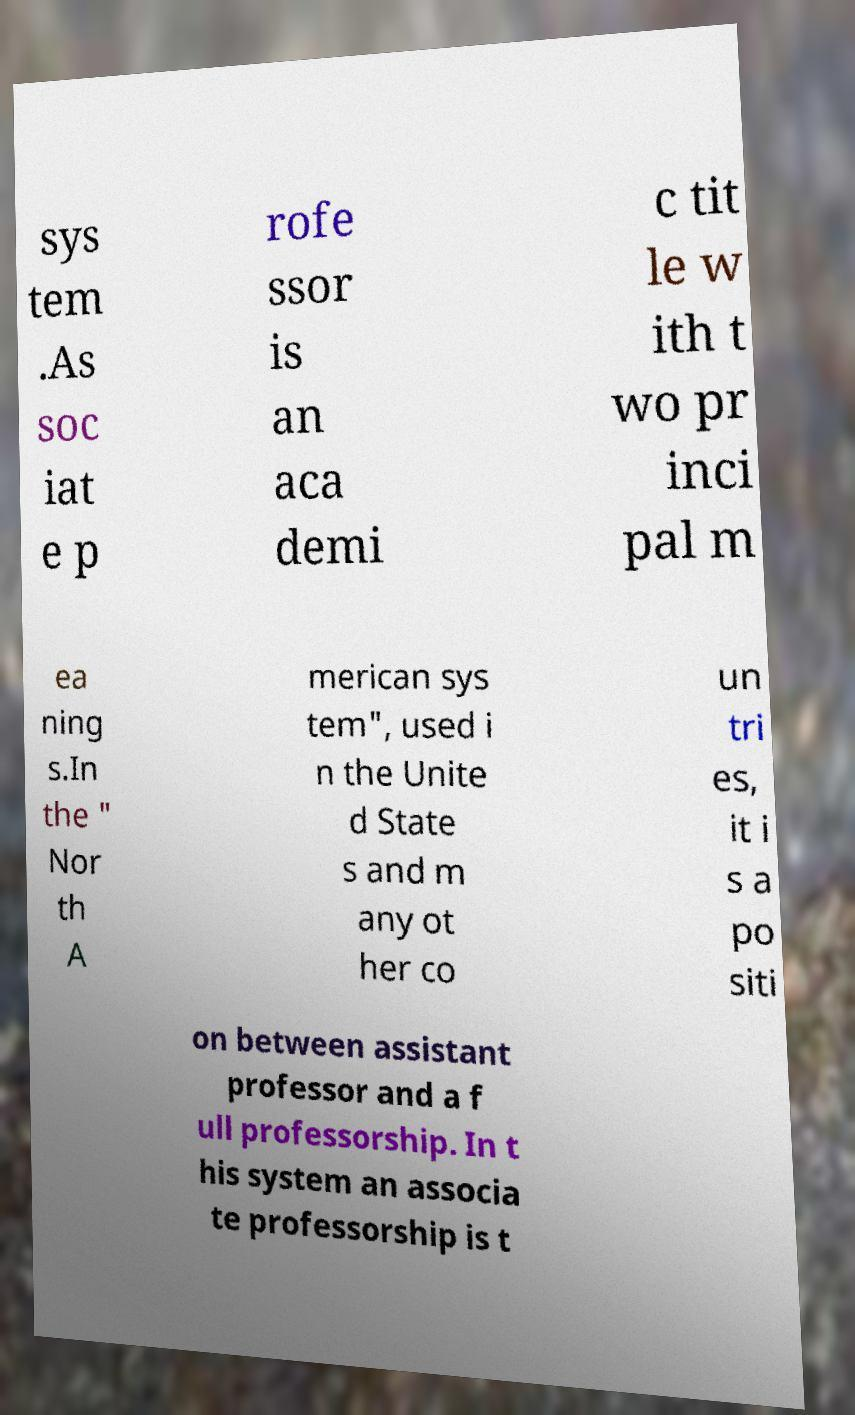I need the written content from this picture converted into text. Can you do that? sys tem .As soc iat e p rofe ssor is an aca demi c tit le w ith t wo pr inci pal m ea ning s.In the " Nor th A merican sys tem", used i n the Unite d State s and m any ot her co un tri es, it i s a po siti on between assistant professor and a f ull professorship. In t his system an associa te professorship is t 